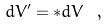Convert formula to latex. <formula><loc_0><loc_0><loc_500><loc_500>d V ^ { \prime } = * d V \ ,</formula> 